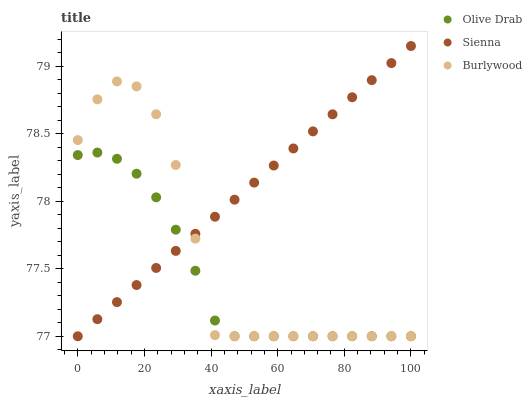Does Olive Drab have the minimum area under the curve?
Answer yes or no. Yes. Does Sienna have the maximum area under the curve?
Answer yes or no. Yes. Does Burlywood have the minimum area under the curve?
Answer yes or no. No. Does Burlywood have the maximum area under the curve?
Answer yes or no. No. Is Sienna the smoothest?
Answer yes or no. Yes. Is Burlywood the roughest?
Answer yes or no. Yes. Is Olive Drab the smoothest?
Answer yes or no. No. Is Olive Drab the roughest?
Answer yes or no. No. Does Sienna have the lowest value?
Answer yes or no. Yes. Does Sienna have the highest value?
Answer yes or no. Yes. Does Burlywood have the highest value?
Answer yes or no. No. Does Olive Drab intersect Burlywood?
Answer yes or no. Yes. Is Olive Drab less than Burlywood?
Answer yes or no. No. Is Olive Drab greater than Burlywood?
Answer yes or no. No. 